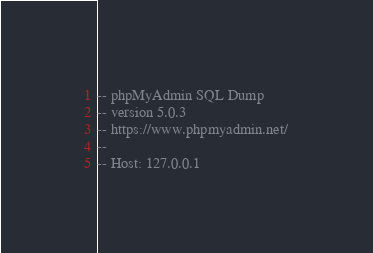Convert code to text. <code><loc_0><loc_0><loc_500><loc_500><_SQL_>-- phpMyAdmin SQL Dump
-- version 5.0.3
-- https://www.phpmyadmin.net/
--
-- Host: 127.0.0.1</code> 